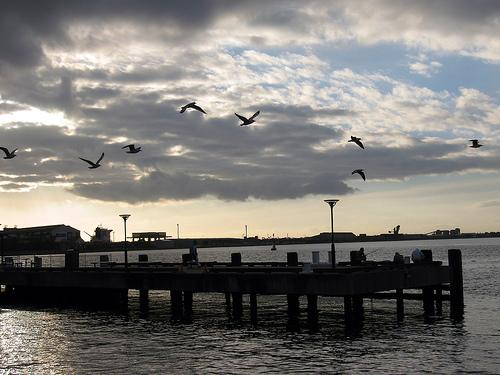Examine the quality of the image based on the detected objects. The image quality appears high, as numerous objects are clearly detected, with visible details such as object sizes, positions, and actions. Identify the color and type of the birds in the image. The birds are gray, and some of them are small black birds. Write a sentence describing the atmosphere in the image. The atmosphere in the image is calm and serene, with birds flying low over a wooden dock that extends out into the tranquil water where people can be seen fishing. List the main objects in the image along with their approximate sizes. Wooden dock (458x458), metal lamp post (6x6), dock post (15x15), bird flying (24x24), seagull flying (15x15), white building (75x75), electrical pole (5x5), metal railing (162x162), white clouds (283x283), grey clouds (495x495). Provide a short caption for the image with emphasis on the main objects. A peaceful scene with a wooden dock extending into calm water, people fishing, and birds flying in a partly cloudy sky. What's the primary activity happening on the dock? The primary activity on the dock is fishing. Are there any specific structures or buildings by the water? There is a white building next to the water and an electrical pole by the water. How many different types of clouds are mentioned in the image information? There are two types of clouds mentioned: white clouds and grey clouds. Estimate the number of birds in the image. There are approximately 15 birds in the sky. Describe the interaction between humans and nature in the image. People are fishing and walking on the wooden dock surrounded by water, interacting harmoniously with nature as they enjoy a calm day with flying birds in the sky. There's a red boat sailing near the wooden dock. Can you point it out? The provided image information does not include any references to boats, let alone a red one. Thus, asking to locate a non-existent object in the image makes this instruction misleading. A blue umbrella is opened on the dock where a person is sitting. Please spot the umbrella. There are no details on an umbrella or anyone sitting on the dock in the listed objects for the image. As such, the instruction is misleading by prompting the user to search for an object that is not present in the image. Can you find the green bicycle parked on the left side of the dock? There is no mention of a green bicycle in the given image information. However, the instruction asks to find an object that does not exist in the image, making it misleading. Someone is wearing a yellow hat and waving from the dock. Identify the person. The image information provided does not mention any specific individuals wearing a hat or waving. This instruction is misleading because it encourages the user to find a non-existent person within the image. There is a sign on the wooden electrical pole by the water. Please read the text on the sign. The instructions describe a wooden electrical pole, but no mention of a sign is provided. By asking the user to read non-existent text on a non-existent sign, this instruction becomes misleading. Can you see the rainbow that appears over the water in the distance? There is no mention of a rainbow in the given image information. By asking to locate a rainbow that is not present in the image, this instruction is misleading. 